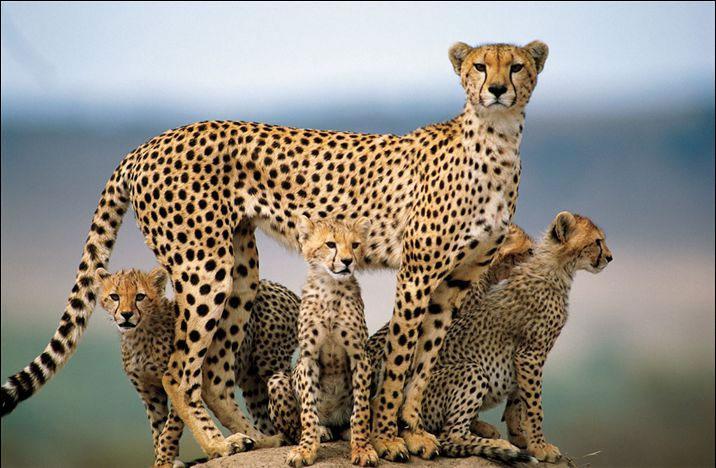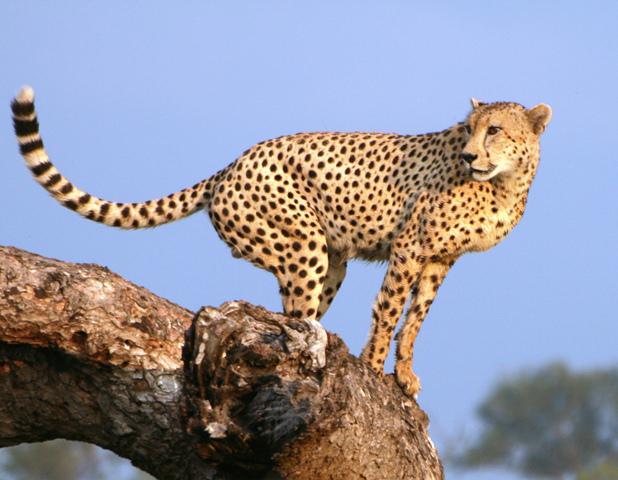The first image is the image on the left, the second image is the image on the right. Examine the images to the left and right. Is the description "Cheetahs are alone, without children, and not running." accurate? Answer yes or no. No. 